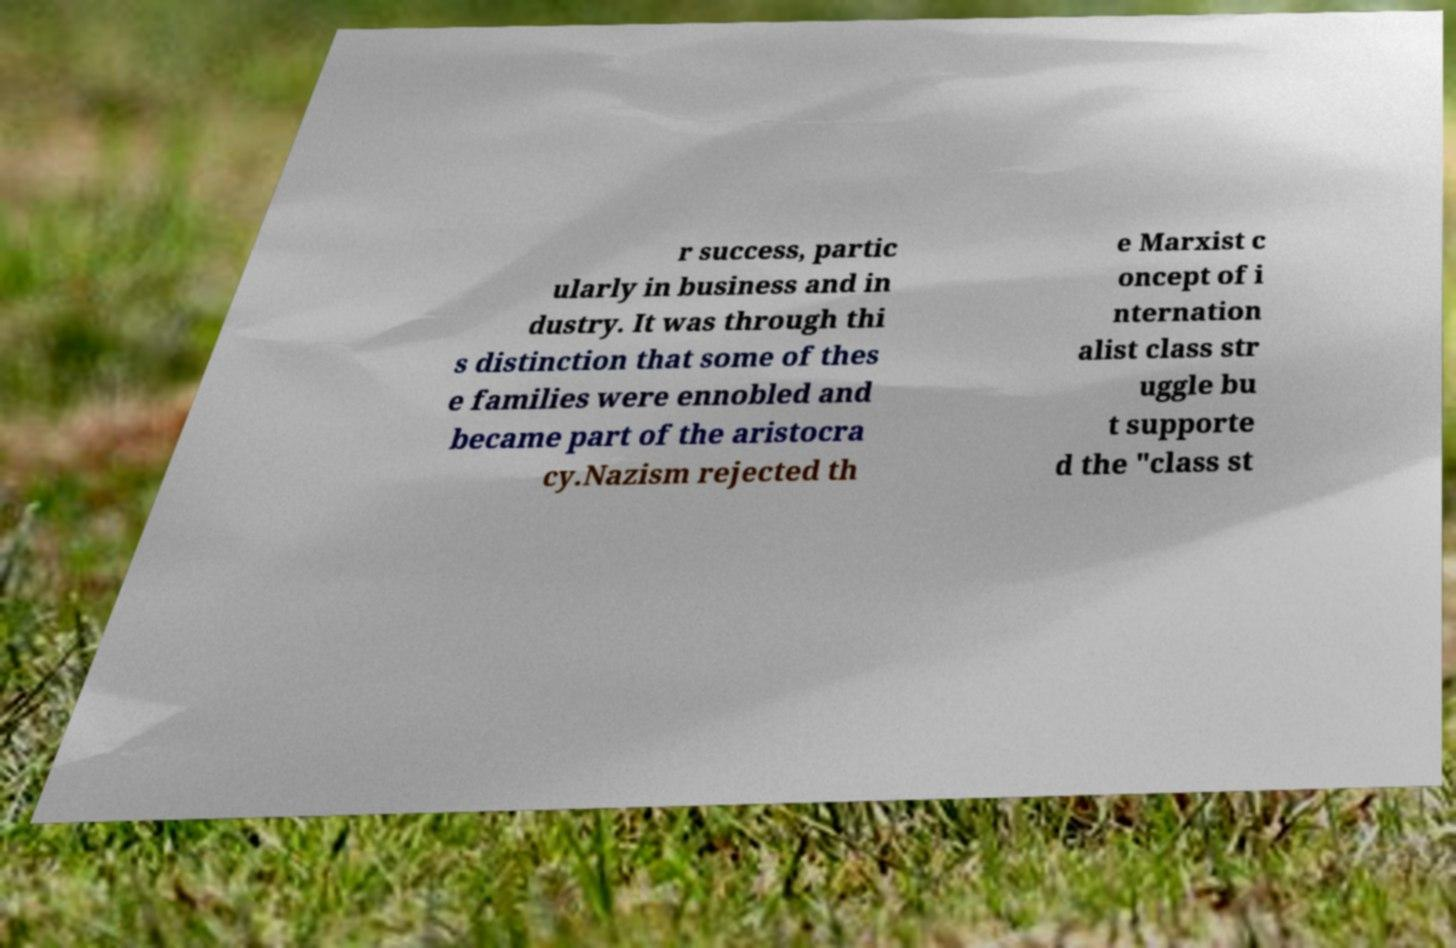What messages or text are displayed in this image? I need them in a readable, typed format. r success, partic ularly in business and in dustry. It was through thi s distinction that some of thes e families were ennobled and became part of the aristocra cy.Nazism rejected th e Marxist c oncept of i nternation alist class str uggle bu t supporte d the "class st 